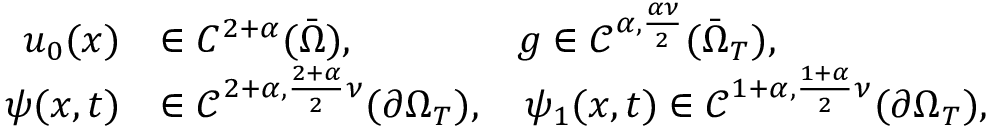<formula> <loc_0><loc_0><loc_500><loc_500>\begin{array} { r l } { u _ { 0 } ( x ) } & { \in C ^ { 2 + \alpha } ( \bar { \Omega } ) , \quad g \in \mathcal { C } ^ { \alpha , \frac { \alpha \nu } { 2 } } ( \bar { \Omega } _ { T } ) , } \\ { \psi ( x , t ) } & { \in \mathcal { C } ^ { 2 + \alpha , \frac { 2 + \alpha } { 2 } \nu } ( \partial \Omega _ { T } ) , \quad \psi _ { 1 } ( x , t ) \in \mathcal { C } ^ { 1 + \alpha , \frac { 1 + \alpha } { 2 } \nu } ( \partial \Omega _ { T } ) , } \end{array}</formula> 